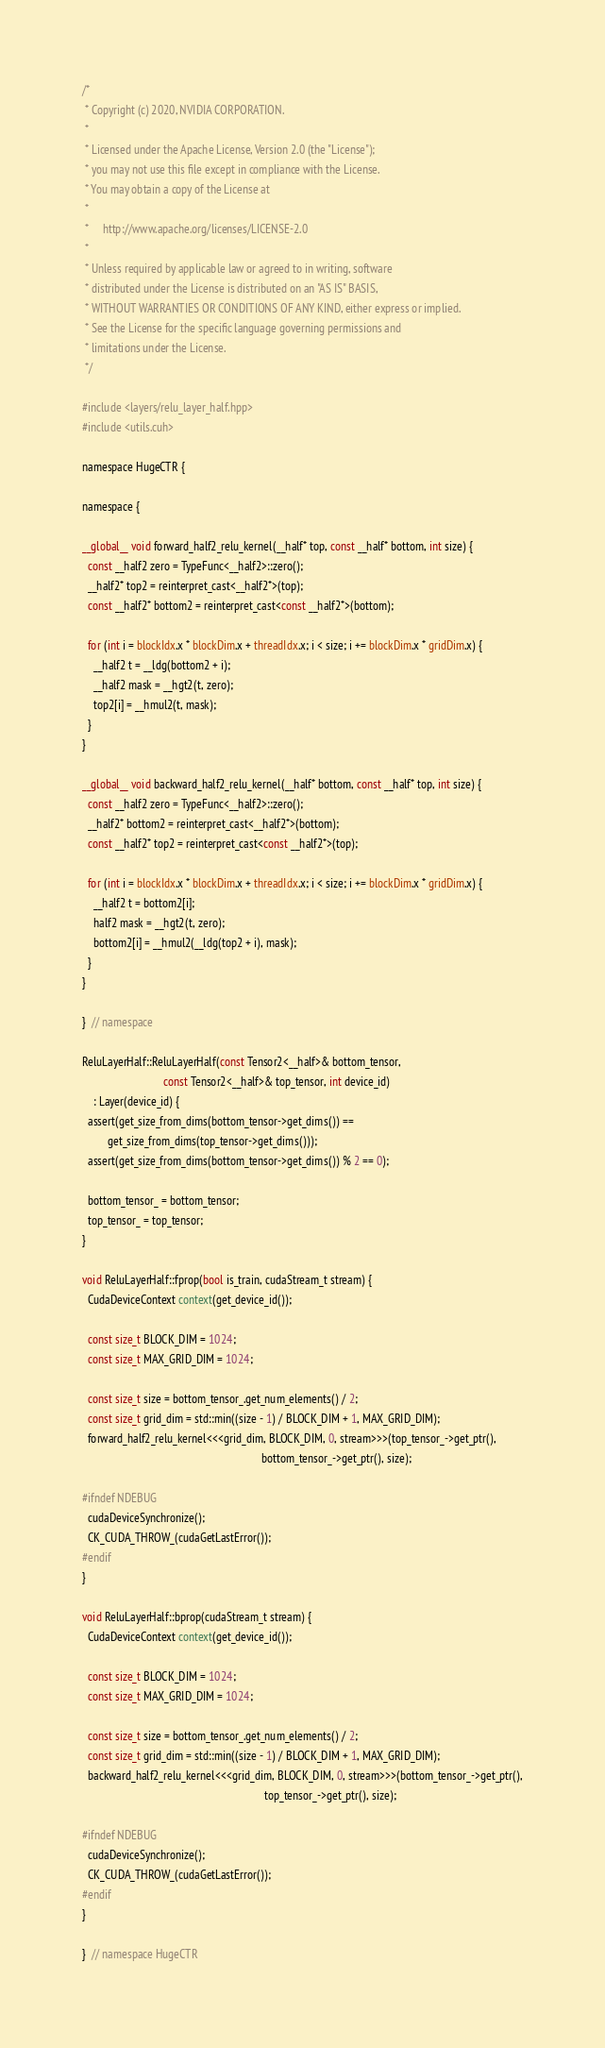<code> <loc_0><loc_0><loc_500><loc_500><_Cuda_>/*
 * Copyright (c) 2020, NVIDIA CORPORATION.
 *
 * Licensed under the Apache License, Version 2.0 (the "License");
 * you may not use this file except in compliance with the License.
 * You may obtain a copy of the License at
 *
 *     http://www.apache.org/licenses/LICENSE-2.0
 *
 * Unless required by applicable law or agreed to in writing, software
 * distributed under the License is distributed on an "AS IS" BASIS,
 * WITHOUT WARRANTIES OR CONDITIONS OF ANY KIND, either express or implied.
 * See the License for the specific language governing permissions and
 * limitations under the License.
 */

#include <layers/relu_layer_half.hpp>
#include <utils.cuh>

namespace HugeCTR {

namespace {

__global__ void forward_half2_relu_kernel(__half* top, const __half* bottom, int size) {
  const __half2 zero = TypeFunc<__half2>::zero();
  __half2* top2 = reinterpret_cast<__half2*>(top);
  const __half2* bottom2 = reinterpret_cast<const __half2*>(bottom);

  for (int i = blockIdx.x * blockDim.x + threadIdx.x; i < size; i += blockDim.x * gridDim.x) {
    __half2 t = __ldg(bottom2 + i);
    __half2 mask = __hgt2(t, zero);
    top2[i] = __hmul2(t, mask);
  }
}

__global__ void backward_half2_relu_kernel(__half* bottom, const __half* top, int size) {
  const __half2 zero = TypeFunc<__half2>::zero();
  __half2* bottom2 = reinterpret_cast<__half2*>(bottom);
  const __half2* top2 = reinterpret_cast<const __half2*>(top);

  for (int i = blockIdx.x * blockDim.x + threadIdx.x; i < size; i += blockDim.x * gridDim.x) {
    __half2 t = bottom2[i];
    half2 mask = __hgt2(t, zero);
    bottom2[i] = __hmul2(__ldg(top2 + i), mask);
  }
}

}  // namespace

ReluLayerHalf::ReluLayerHalf(const Tensor2<__half>& bottom_tensor,
                             const Tensor2<__half>& top_tensor, int device_id)
    : Layer(device_id) {
  assert(get_size_from_dims(bottom_tensor->get_dims()) ==
         get_size_from_dims(top_tensor->get_dims()));
  assert(get_size_from_dims(bottom_tensor->get_dims()) % 2 == 0);

  bottom_tensor_ = bottom_tensor;
  top_tensor_ = top_tensor;
}

void ReluLayerHalf::fprop(bool is_train, cudaStream_t stream) {
  CudaDeviceContext context(get_device_id());

  const size_t BLOCK_DIM = 1024;
  const size_t MAX_GRID_DIM = 1024;

  const size_t size = bottom_tensor_.get_num_elements() / 2;
  const size_t grid_dim = std::min((size - 1) / BLOCK_DIM + 1, MAX_GRID_DIM);
  forward_half2_relu_kernel<<<grid_dim, BLOCK_DIM, 0, stream>>>(top_tensor_->get_ptr(),
                                                                bottom_tensor_->get_ptr(), size);

#ifndef NDEBUG
  cudaDeviceSynchronize();
  CK_CUDA_THROW_(cudaGetLastError());
#endif
}

void ReluLayerHalf::bprop(cudaStream_t stream) {
  CudaDeviceContext context(get_device_id());

  const size_t BLOCK_DIM = 1024;
  const size_t MAX_GRID_DIM = 1024;

  const size_t size = bottom_tensor_.get_num_elements() / 2;
  const size_t grid_dim = std::min((size - 1) / BLOCK_DIM + 1, MAX_GRID_DIM);
  backward_half2_relu_kernel<<<grid_dim, BLOCK_DIM, 0, stream>>>(bottom_tensor_->get_ptr(),
                                                                 top_tensor_->get_ptr(), size);

#ifndef NDEBUG
  cudaDeviceSynchronize();
  CK_CUDA_THROW_(cudaGetLastError());
#endif
}

}  // namespace HugeCTR
</code> 